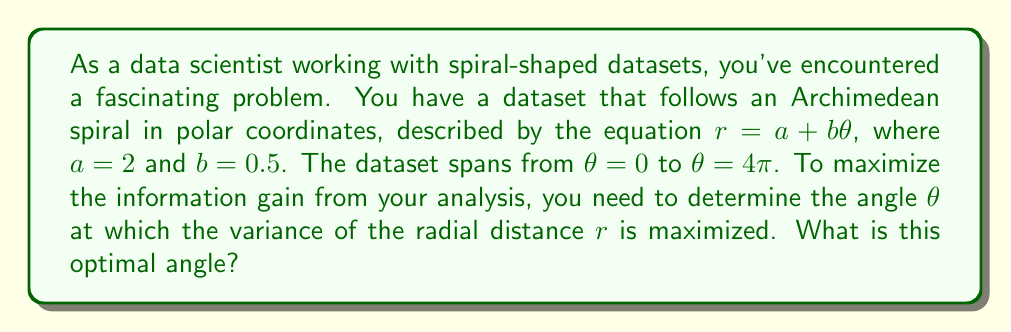What is the answer to this math problem? To solve this problem, we'll follow these steps:

1) In an Archimedean spiral, the variance of $r$ increases as $\theta$ increases. The maximum variance will occur at the largest value of $\theta$, which in this case is $4\pi$.

2) To verify this mathematically, we can calculate the variance of $r$ as a function of $\theta$:

   The mean of $r$ from 0 to $\theta$ is:
   $$\bar{r} = \frac{1}{\theta}\int_0^\theta (a + b\phi) d\phi = a + \frac{b\theta}{2}$$

   The variance of $r$ is:
   $$\begin{align}
   Var(r) &= \frac{1}{\theta}\int_0^\theta ((a + b\phi) - (a + \frac{b\theta}{2}))^2 d\phi \\
   &= \frac{1}{\theta}\int_0^\theta (b\phi - \frac{b\theta}{2})^2 d\phi \\
   &= \frac{b^2}{\theta}\int_0^\theta (\phi^2 - \theta\phi + \frac{\theta^2}{4}) d\phi \\
   &= \frac{b^2}{\theta}[\frac{\phi^3}{3} - \frac{\theta\phi^2}{2} + \frac{\theta^2\phi}{4}]_0^\theta \\
   &= \frac{b^2\theta^2}{12}
   \end{align}$$

3) We can see that the variance is proportional to $\theta^2$, so it increases monotonically with $\theta$.

4) Therefore, the maximum variance occurs at the maximum value of $\theta$, which is $4\pi$.

5) To calculate the actual value of the maximum variance:
   $$Var(r)_{max} = \frac{b^2(4\pi)^2}{12} = \frac{0.5^2(4\pi)^2}{12} \approx 2.0944$$

6) The corresponding $r$ value at this $\theta$ is:
   $$r = a + b\theta = 2 + 0.5(4\pi) \approx 8.2832$$

[asy]
import graph;
size(200);
real a = 2;
real b = 0.5;
real theta_max = 4*pi;

path spiral;
for (real t = 0; t <= theta_max; t += 0.01) {
  real r = a + b*t;
  pair p = r*dir(t*180/pi);
  spiral = spiral--p;
}

draw(spiral, blue);
draw(arc((0,0), 8.2832, 0, 360*4), dashed+red);
label("$\theta = 4\pi$", (4,7), E);
dot((8.2832,0), red);
[/asy]
Answer: The optimal angle for maximum variance in the spiral-shaped dataset is $\theta = 4\pi$ radians, corresponding to a radial distance of $r \approx 8.2832$. 